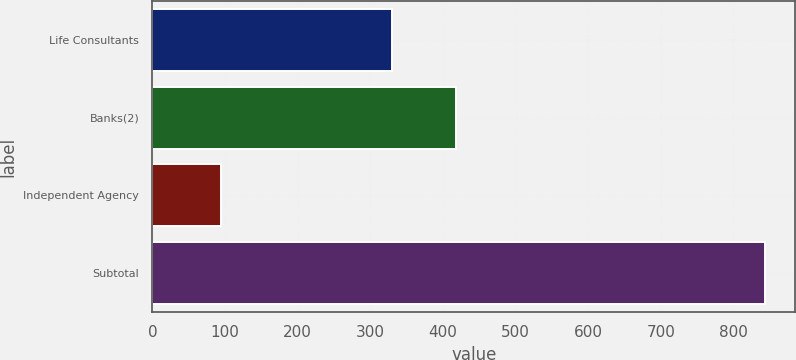Convert chart to OTSL. <chart><loc_0><loc_0><loc_500><loc_500><bar_chart><fcel>Life Consultants<fcel>Banks(2)<fcel>Independent Agency<fcel>Subtotal<nl><fcel>330<fcel>418<fcel>95<fcel>843<nl></chart> 